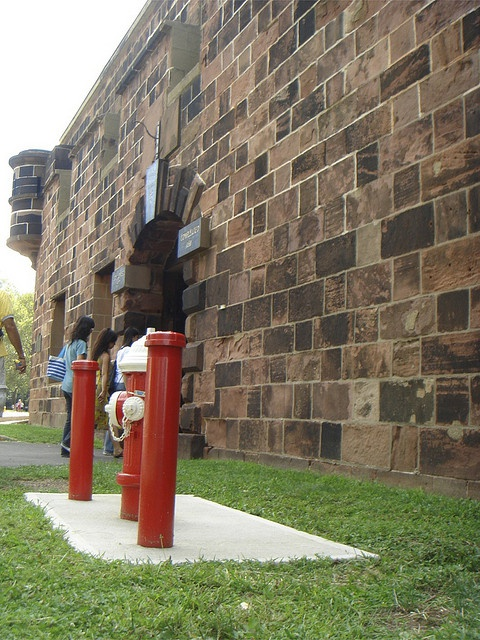Describe the objects in this image and their specific colors. I can see fire hydrant in white and brown tones, people in white, black, gray, and darkgray tones, people in white, black, olive, gray, and maroon tones, people in white, gray, tan, and darkgray tones, and people in white, black, and gray tones in this image. 